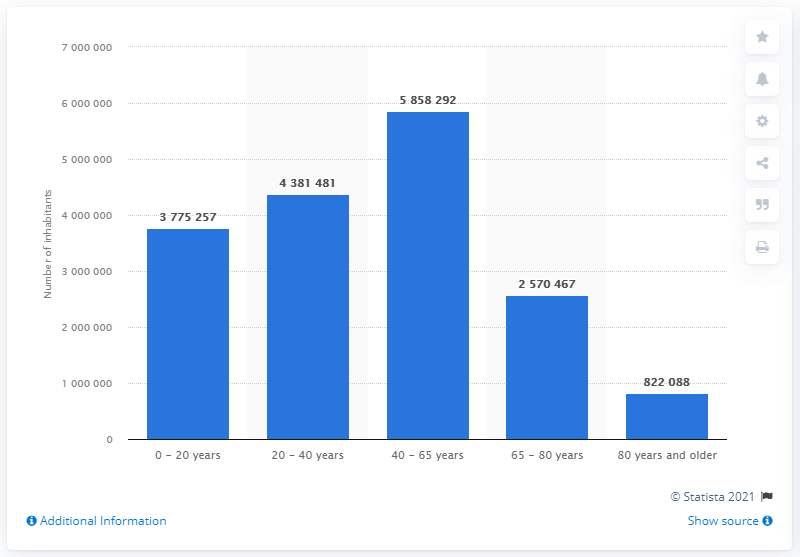Outline some significant characteristics in this image. There are approximately 377,525,701 retired people living in the Netherlands. The age range with the most population is 40-65 years old. As of January 1, 2020, there were 377,525 individuals aged between 40 and 65 living in the Netherlands. As of January 1, 2020, there were 377,525 people younger than 20 years old living in the Netherlands. The age range of 0-20 years has more population than the age range of 65-80 years. 